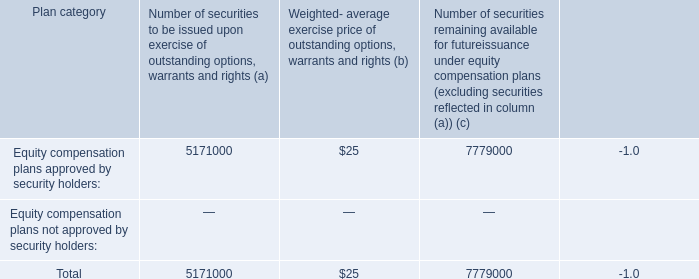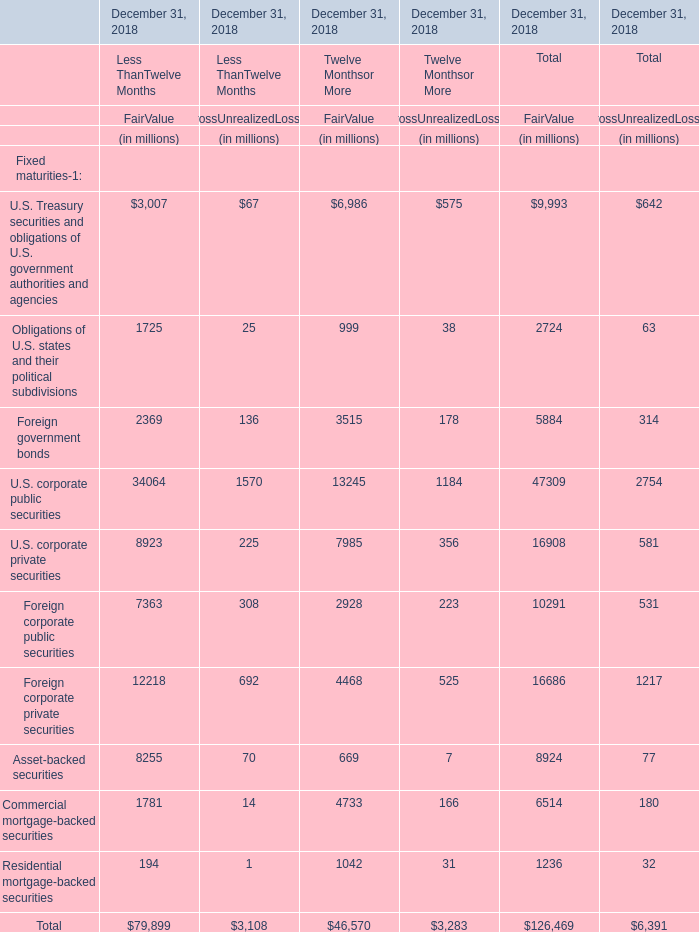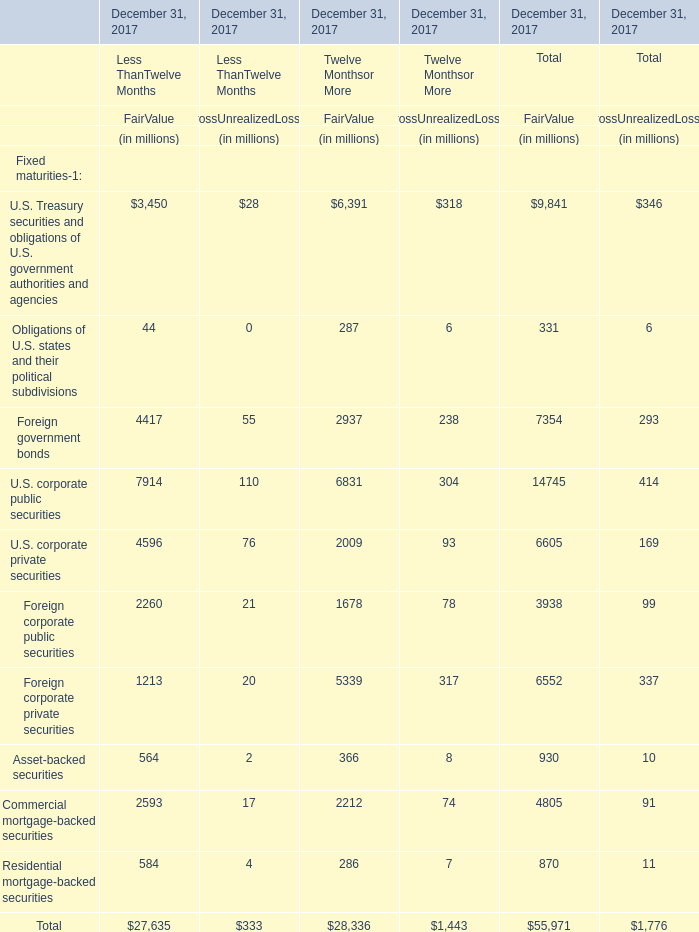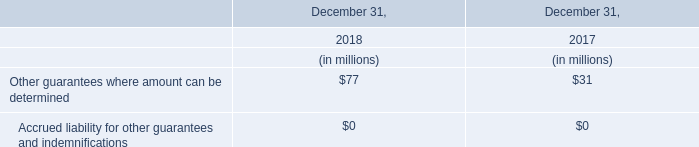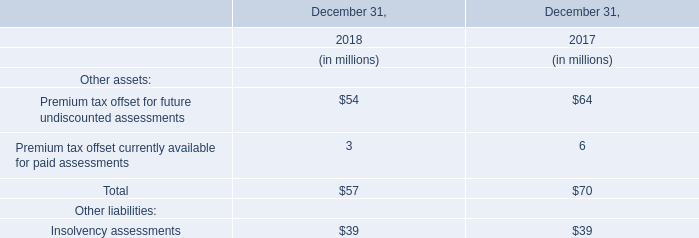What's the sum of all elements that are greater than 10000 for FairValue of Less ThanTwelve Months? (in million) 
Computations: (34064 + 12218)
Answer: 46282.0. 